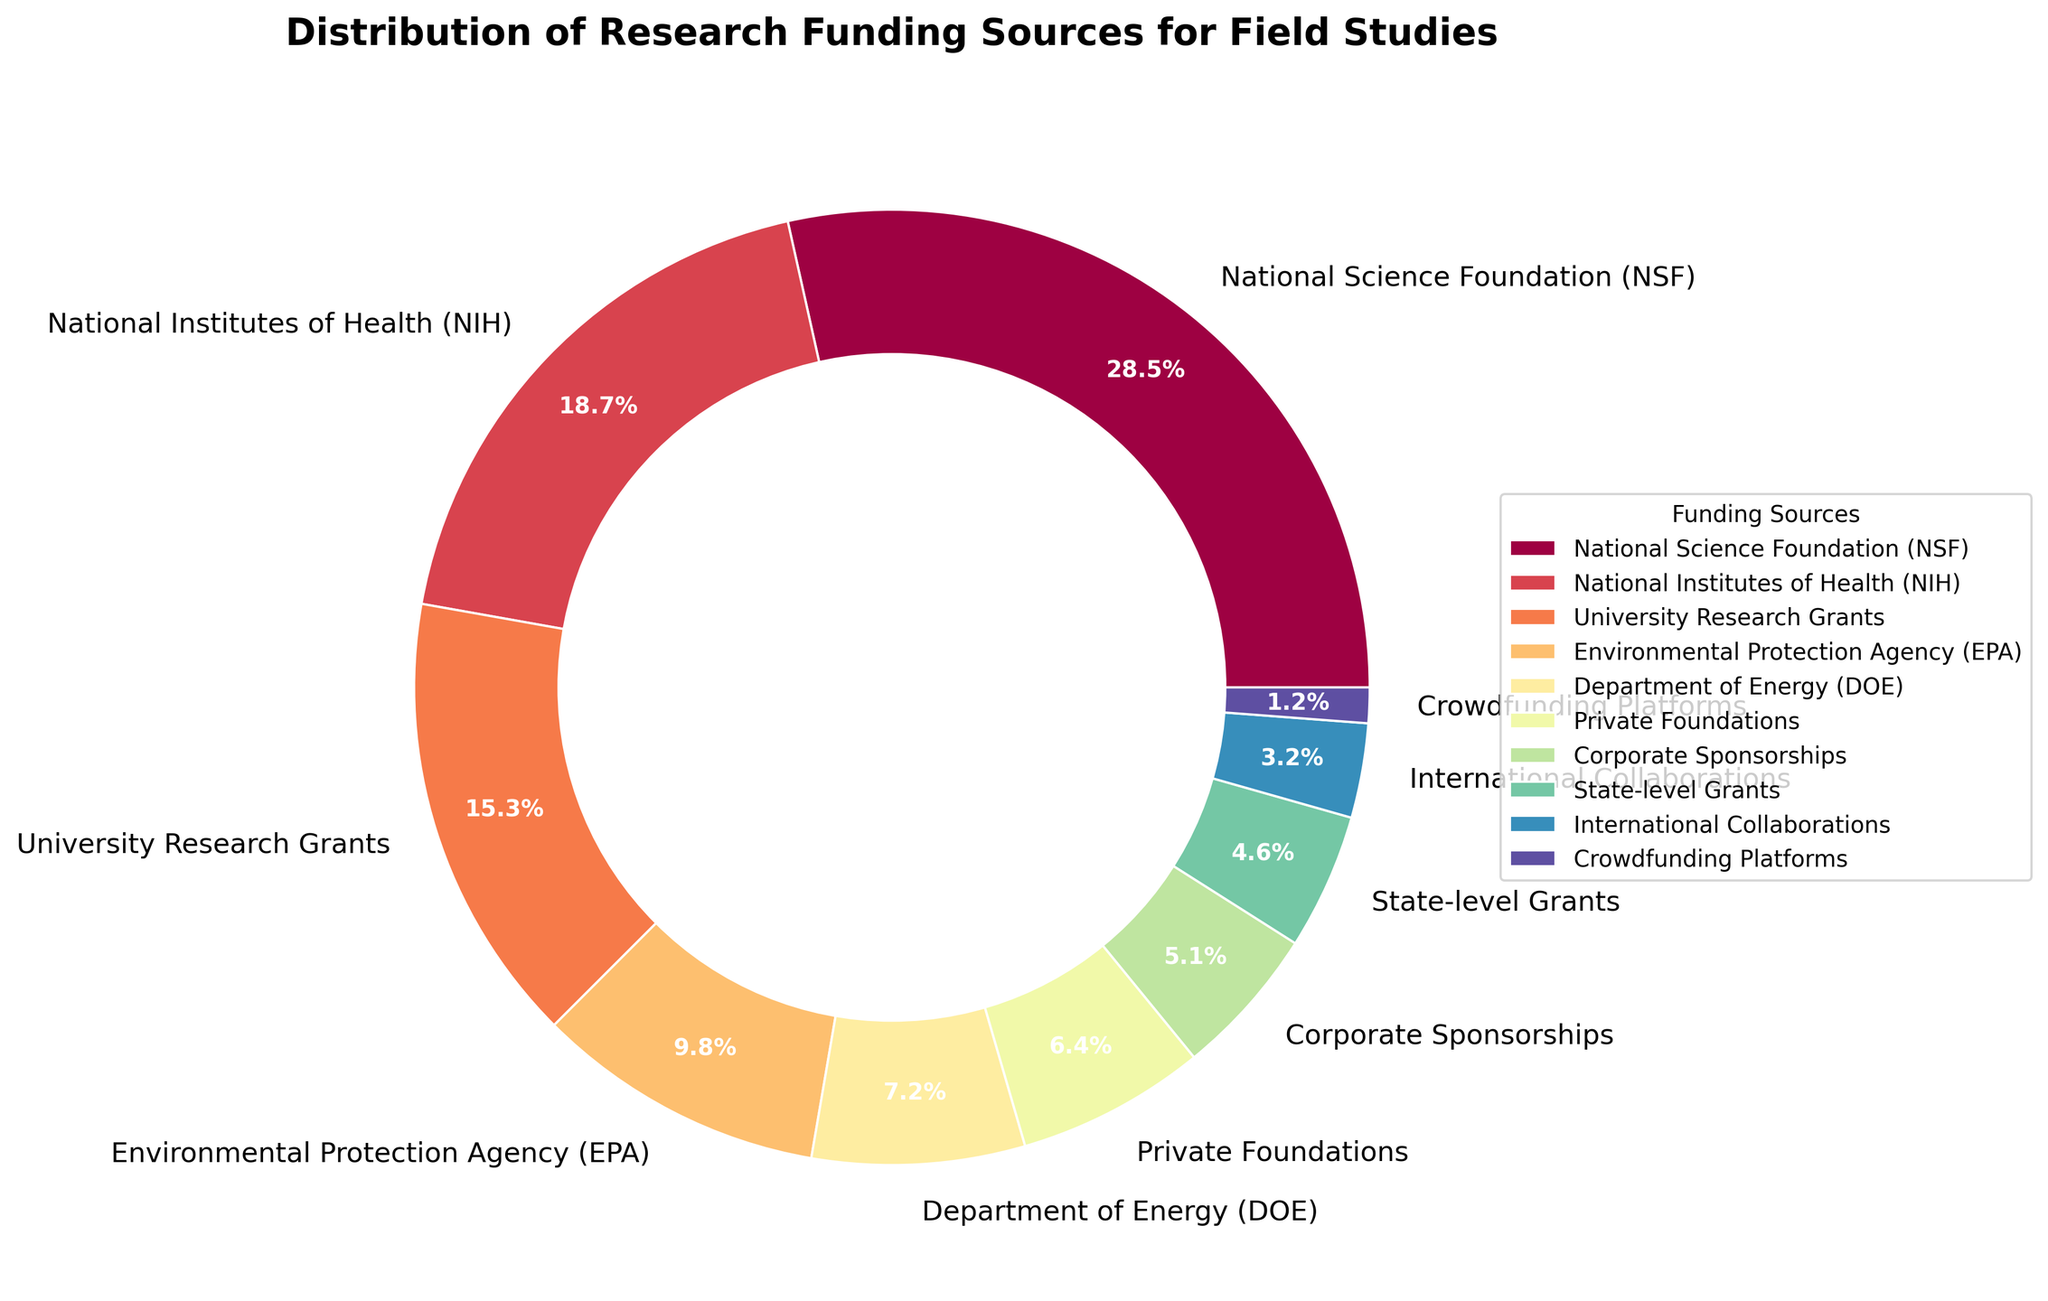What is the funding source with the highest percentage? To find the funding source with the highest percentage, look at the labels and corresponding percentages in the pie chart. The largest percentage is 28.5%, which is labeled as National Science Foundation (NSF).
Answer: National Science Foundation (NSF) Which funding sources together make up more than 50% of the total funding? To determine which funding sources together make up more than half, start combining percentages from the highest down until the sum exceeds 50%. NSF (28.5%) + NIH (18.7%) makes 47.2%, adding University Research Grants (15.3%) results in a total of 62.5%. These three sources combined exceed 50%.
Answer: NSF, NIH, and University Research Grants What is the difference in funding percentages between Corporate Sponsorships and Private Foundations? Identify the percentages for Corporate Sponsorships (5.1%) and Private Foundations (6.4%) from the chart. Subtract the smaller percentage from the larger one: 6.4% - 5.1% = 1.3%.
Answer: 1.3% How much larger is the funding percentage from the NSF compared to the EPA? Get the percentages from the pie chart: NSF (28.5%) and EPA (9.8%). Subtract the EPA percentage from the NSF percentage: 28.5% - 9.8% = 18.7%.
Answer: 18.7% Which funding source contributes the least to the total funding? By examining the pie chart for the smallest percentage, Crowdfunding Platforms has the smallest share at 1.2%.
Answer: Crowdfunding Platforms Rank the top three funding sources based on their funding percentages. Refer to the percentages to identify the top three: NSF (28.5%), NIH (18.7%), and University Research Grants (15.3%). List these in descending order of their percentages.
Answer: NSF, NIH, University Research Grants What is the total percentage contribution of the Department of Energy (DOE) and State-level Grants? Find the percentages for DOE (7.2%) and State-level Grants (4.6%). Add them together: 7.2% + 4.6% = 11.8%.
Answer: 11.8% Which funding category falls between Corporate Sponsorships and Private Foundations in percentage terms? Locate the percentages for Corporate Sponsorships (5.1%) and Private Foundations (6.4%), then identify the funding category in between these values. The DOE at 7.2% fits next closest but is higher, so none fall exactly between these two values.
Answer: None 